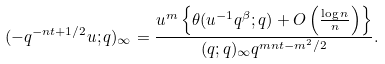<formula> <loc_0><loc_0><loc_500><loc_500>( - q ^ { - n t + 1 / 2 } u ; q ) _ { \infty } = \frac { u ^ { m } \left \{ \theta ( u ^ { - 1 } q ^ { \beta } ; q ) + O \left ( \frac { \log n } { n } \right ) \right \} } { ( q ; q ) _ { \infty } q ^ { m n t - m ^ { 2 } / 2 } } .</formula> 